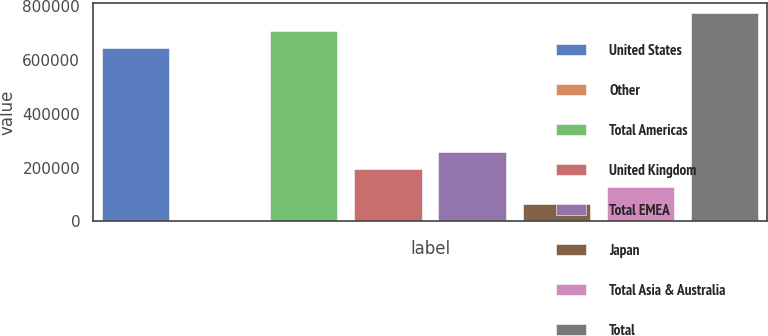Convert chart to OTSL. <chart><loc_0><loc_0><loc_500><loc_500><bar_chart><fcel>United States<fcel>Other<fcel>Total Americas<fcel>United Kingdom<fcel>Total EMEA<fcel>Japan<fcel>Total Asia & Australia<fcel>Total<nl><fcel>643942<fcel>11<fcel>708698<fcel>194278<fcel>259034<fcel>64766.8<fcel>129523<fcel>773454<nl></chart> 